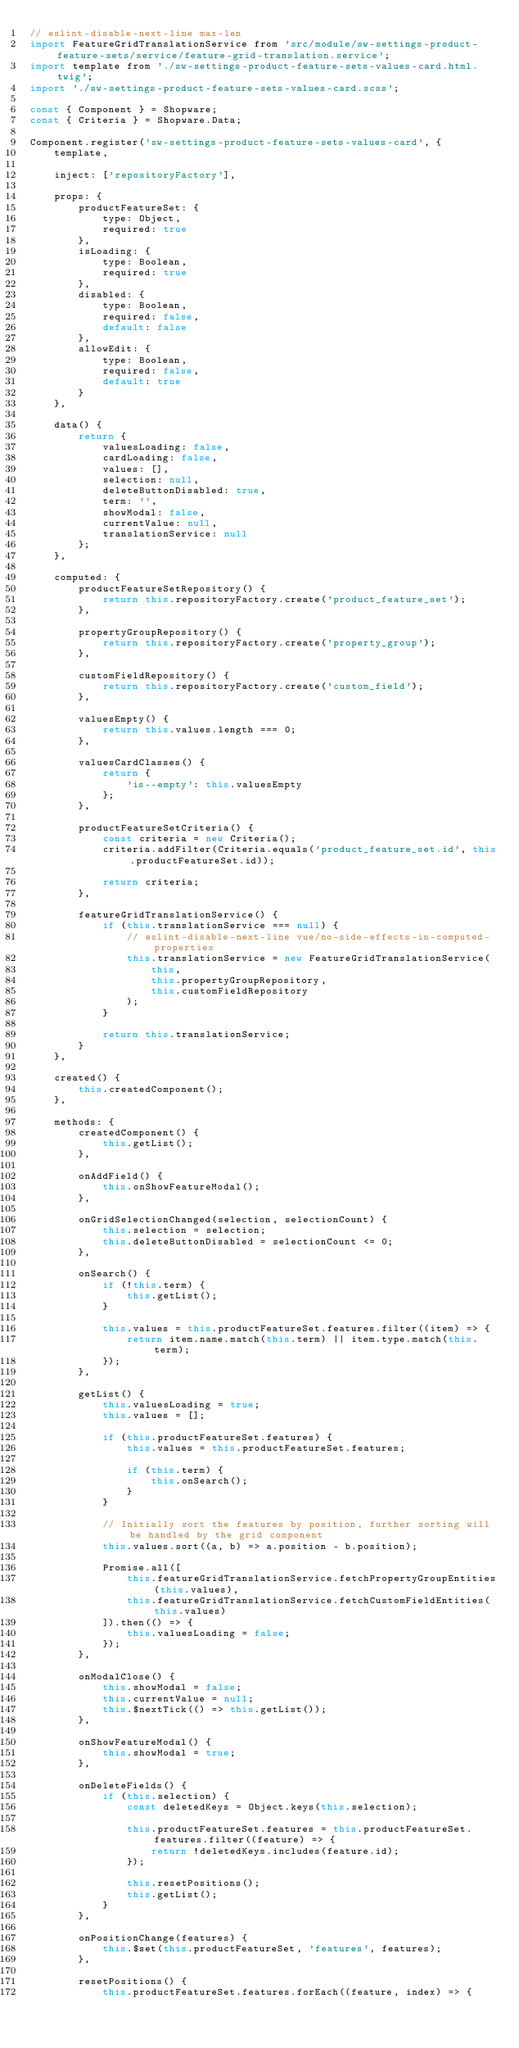<code> <loc_0><loc_0><loc_500><loc_500><_JavaScript_>// eslint-disable-next-line max-len
import FeatureGridTranslationService from 'src/module/sw-settings-product-feature-sets/service/feature-grid-translation.service';
import template from './sw-settings-product-feature-sets-values-card.html.twig';
import './sw-settings-product-feature-sets-values-card.scss';

const { Component } = Shopware;
const { Criteria } = Shopware.Data;

Component.register('sw-settings-product-feature-sets-values-card', {
    template,

    inject: ['repositoryFactory'],

    props: {
        productFeatureSet: {
            type: Object,
            required: true
        },
        isLoading: {
            type: Boolean,
            required: true
        },
        disabled: {
            type: Boolean,
            required: false,
            default: false
        },
        allowEdit: {
            type: Boolean,
            required: false,
            default: true
        }
    },

    data() {
        return {
            valuesLoading: false,
            cardLoading: false,
            values: [],
            selection: null,
            deleteButtonDisabled: true,
            term: '',
            showModal: false,
            currentValue: null,
            translationService: null
        };
    },

    computed: {
        productFeatureSetRepository() {
            return this.repositoryFactory.create('product_feature_set');
        },

        propertyGroupRepository() {
            return this.repositoryFactory.create('property_group');
        },

        customFieldRepository() {
            return this.repositoryFactory.create('custom_field');
        },

        valuesEmpty() {
            return this.values.length === 0;
        },

        valuesCardClasses() {
            return {
                'is--empty': this.valuesEmpty
            };
        },

        productFeatureSetCriteria() {
            const criteria = new Criteria();
            criteria.addFilter(Criteria.equals('product_feature_set.id', this.productFeatureSet.id));

            return criteria;
        },

        featureGridTranslationService() {
            if (this.translationService === null) {
                // eslint-disable-next-line vue/no-side-effects-in-computed-properties
                this.translationService = new FeatureGridTranslationService(
                    this,
                    this.propertyGroupRepository,
                    this.customFieldRepository
                );
            }

            return this.translationService;
        }
    },

    created() {
        this.createdComponent();
    },

    methods: {
        createdComponent() {
            this.getList();
        },

        onAddField() {
            this.onShowFeatureModal();
        },

        onGridSelectionChanged(selection, selectionCount) {
            this.selection = selection;
            this.deleteButtonDisabled = selectionCount <= 0;
        },

        onSearch() {
            if (!this.term) {
                this.getList();
            }

            this.values = this.productFeatureSet.features.filter((item) => {
                return item.name.match(this.term) || item.type.match(this.term);
            });
        },

        getList() {
            this.valuesLoading = true;
            this.values = [];

            if (this.productFeatureSet.features) {
                this.values = this.productFeatureSet.features;

                if (this.term) {
                    this.onSearch();
                }
            }

            // Initially sort the features by position, further sorting will be handled by the grid component
            this.values.sort((a, b) => a.position - b.position);

            Promise.all([
                this.featureGridTranslationService.fetchPropertyGroupEntities(this.values),
                this.featureGridTranslationService.fetchCustomFieldEntities(this.values)
            ]).then(() => {
                this.valuesLoading = false;
            });
        },

        onModalClose() {
            this.showModal = false;
            this.currentValue = null;
            this.$nextTick(() => this.getList());
        },

        onShowFeatureModal() {
            this.showModal = true;
        },

        onDeleteFields() {
            if (this.selection) {
                const deletedKeys = Object.keys(this.selection);

                this.productFeatureSet.features = this.productFeatureSet.features.filter((feature) => {
                    return !deletedKeys.includes(feature.id);
                });

                this.resetPositions();
                this.getList();
            }
        },

        onPositionChange(features) {
            this.$set(this.productFeatureSet, 'features', features);
        },

        resetPositions() {
            this.productFeatureSet.features.forEach((feature, index) => {</code> 